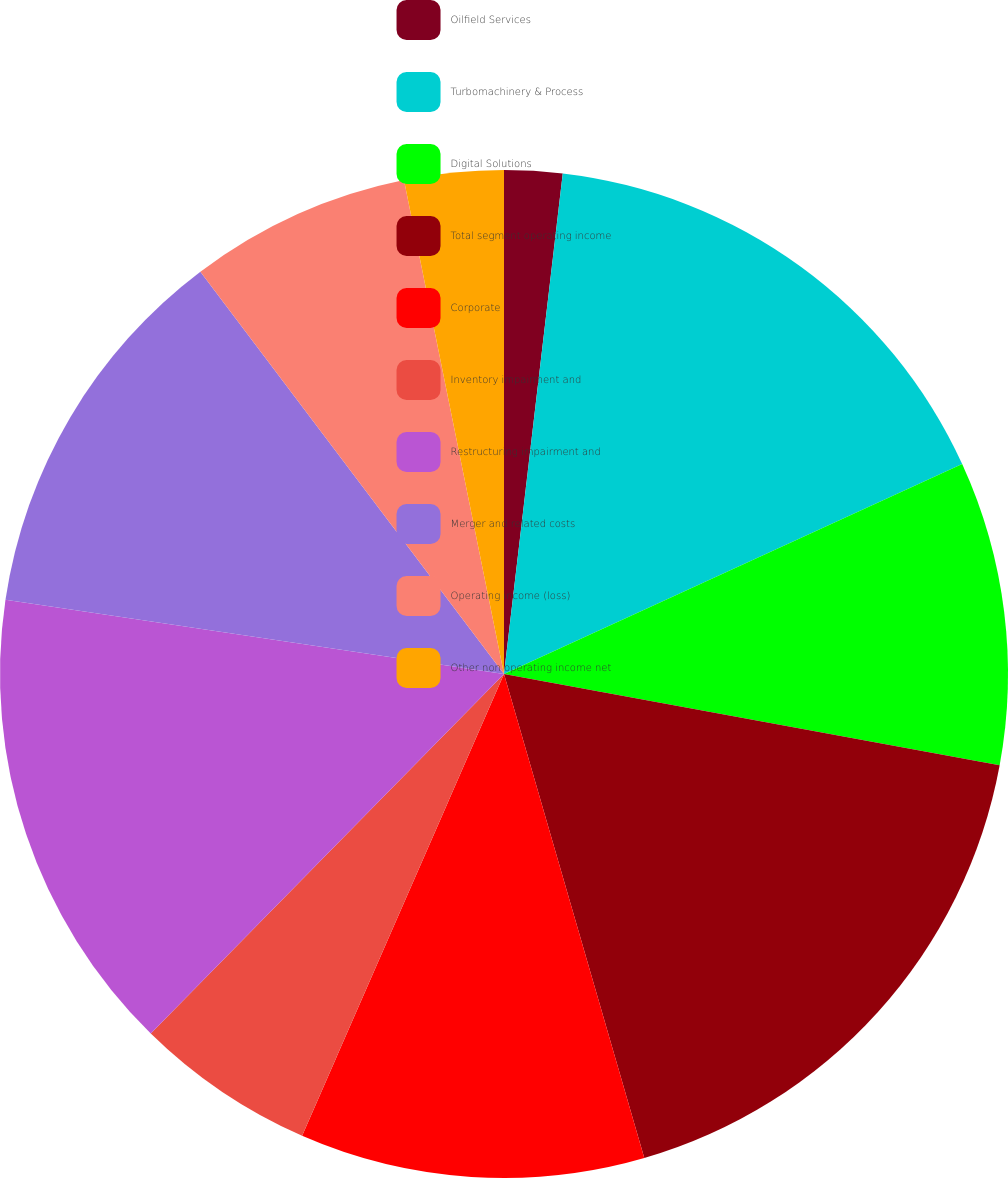<chart> <loc_0><loc_0><loc_500><loc_500><pie_chart><fcel>Oilfield Services<fcel>Turbomachinery & Process<fcel>Digital Solutions<fcel>Total segment operating income<fcel>Corporate<fcel>Inventory impairment and<fcel>Restructuring impairment and<fcel>Merger and related costs<fcel>Operating income (loss)<fcel>Other non operating income net<nl><fcel>1.86%<fcel>16.3%<fcel>9.74%<fcel>17.61%<fcel>11.05%<fcel>5.8%<fcel>14.99%<fcel>12.36%<fcel>7.11%<fcel>3.18%<nl></chart> 